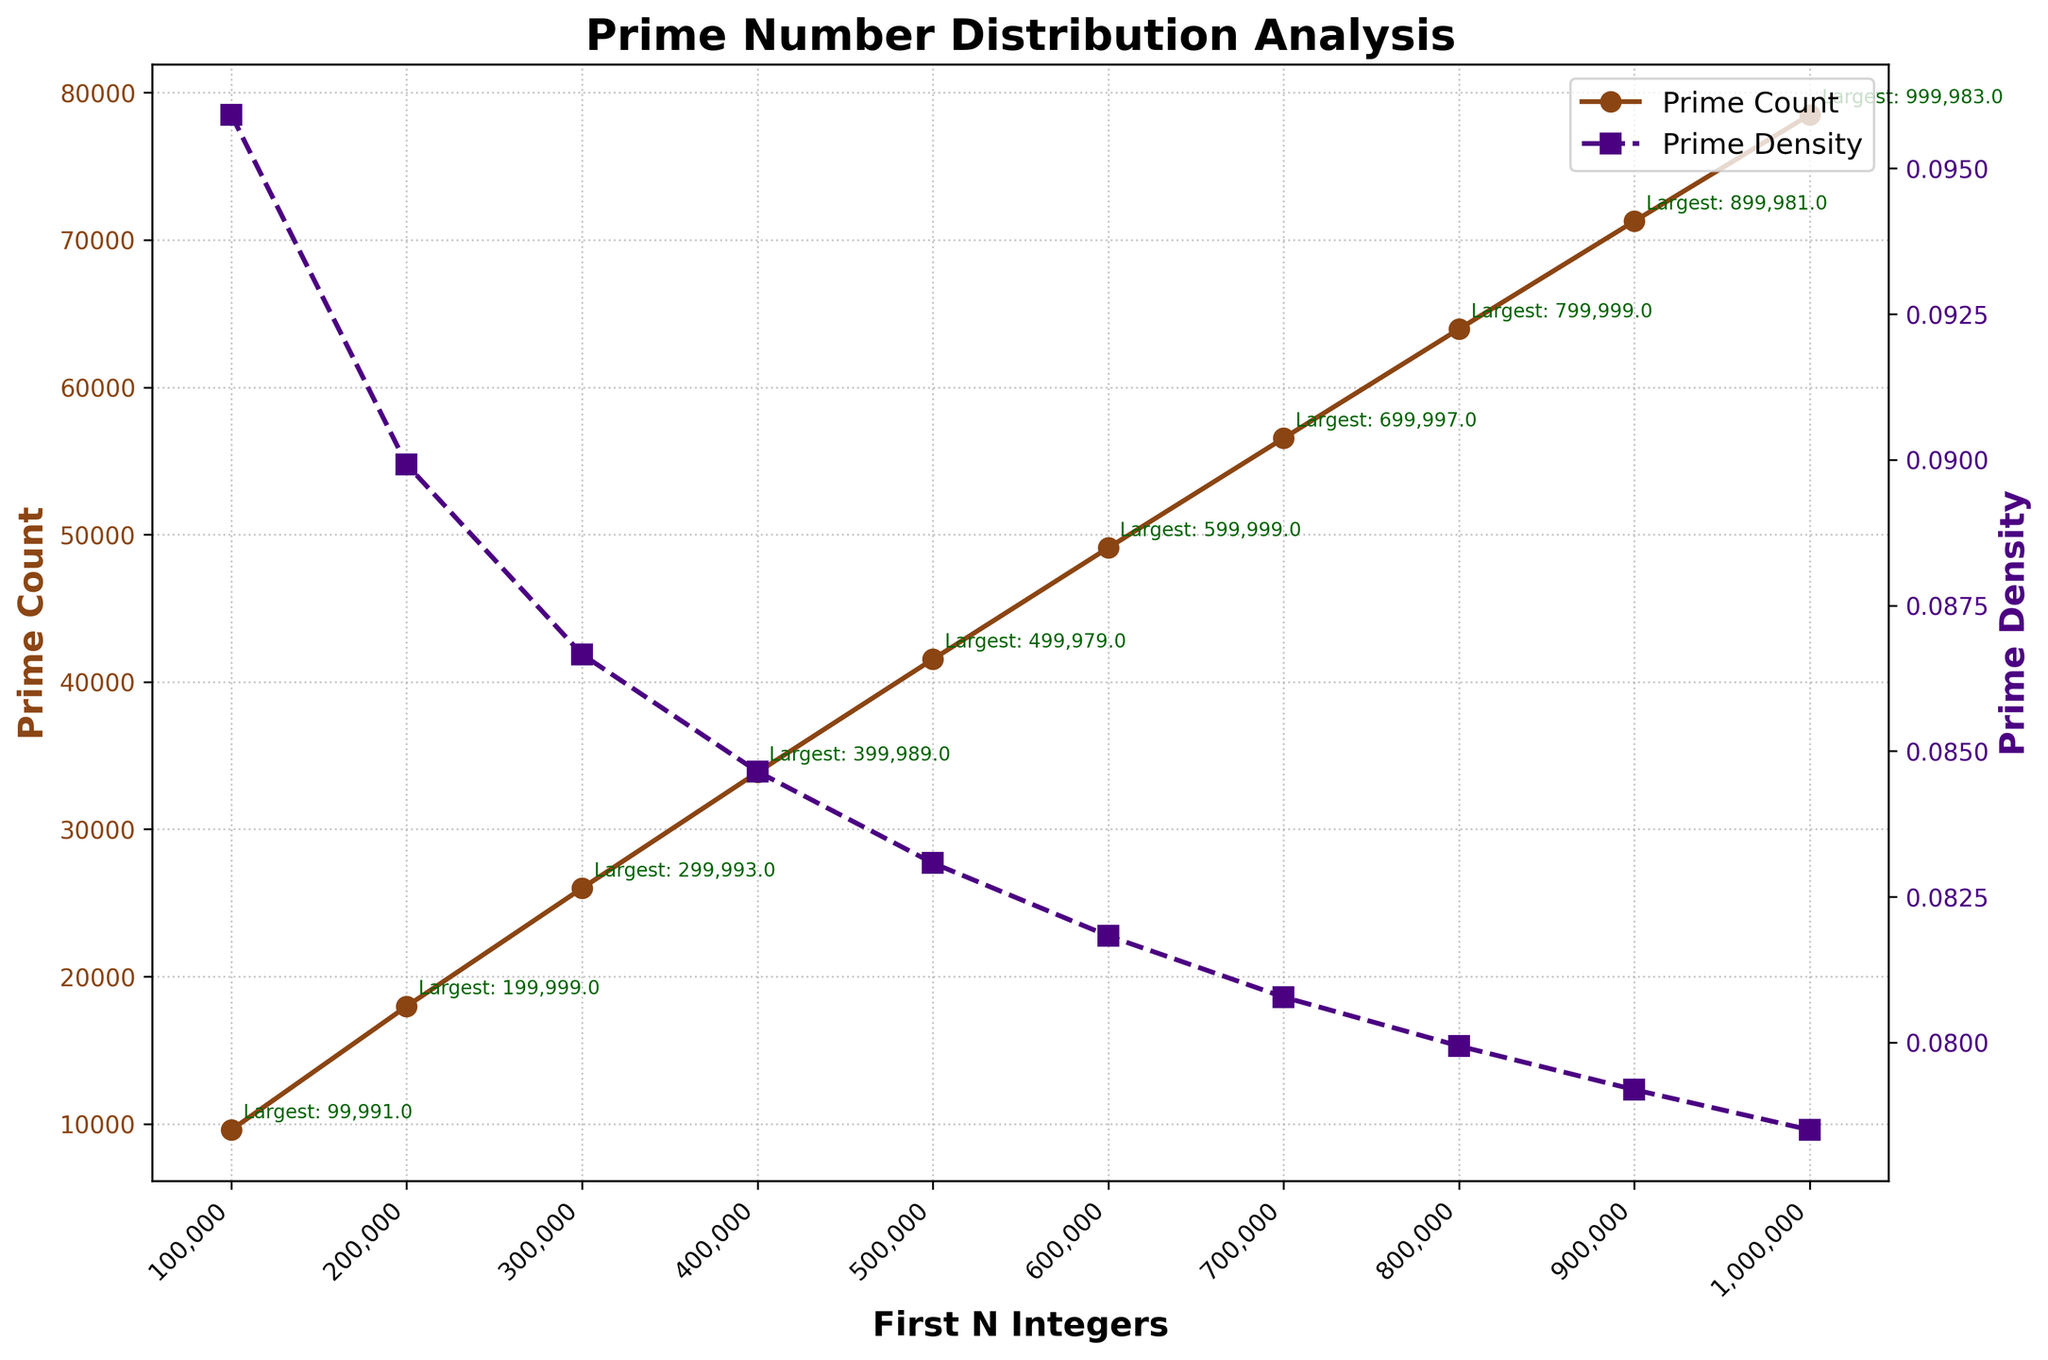What is the prime count when the first N integers reach 600,000? According to the figure, the prime count when the first N integers are at 600,000 is represented by the brown line with circle markers. Look for the corresponding value on the y-axis for the prime count at x = 600,000.
Answer: 49,098 How does the prime density change from N = 100,000 to N = 200,000? The prime density is represented by the purple line with square markers. Compare the y-values of the prime density at x = 100,000 and x = 200,000 to see the change.
Answer: Decreases from 0.09592 to 0.08992 Between which pairs of N values does the largest gap in prime count occur? To find the largest gap in prime count, calculate the differences between consecutive prime counts, i.e., difference between values at x = 200,000 and x = 100,000, and so on. Identify the pair with the largest difference.
Answer: Between 100,000 and 200,000 (difference of 8,392) What is the largest prime number when the first N integers reach 800,000? Look at the annotated text near the brown line at x = 800,000. It indicates the largest prime number at this point.
Answer: 799,999 Compare the trend of prime density and prime count as N increases. Are they in agreement or diverging? Observe the general direction of both prime density and prime count lines. The brown line (prime count) generally increases, while the purple line (prime density) decreases. This indicates they are diverging.
Answer: Diverging How much does the prime density decrease from N = 100,000 to N = 1,000,000? Determine the prime density values at N = 100,000 and at N = 1,000,000. Subtract the smaller value from the larger one to find the decrease amount.
Answer: Decreased by 0.01742 At what N value is the prime density closest to 0.08? Identify the points at which the purple line (prime density) is nearly at 0.08 on the y-axis. Check the x-axis values associated with these points.
Answer: N = 700,000 How does the prime count change relative to the largest prime for N = 400,000? Explain. Look at the annotated text for the largest prime at N = 400,000 and compare it with the prime count value at the same point. Prime count increases as more integers are analyzed, but the largest prime value shows individual prime positions.
Answer: Prime count is 33,860, largest prime is 399,989 By how much does the largest prime number increase between N = 500,000 and N = 1,000,000? Check the annotated largest prime numbers at N = 500,000 and N = 1,000,000 and subtract the smaller value from the larger value.
Answer: Increased by 499,004 